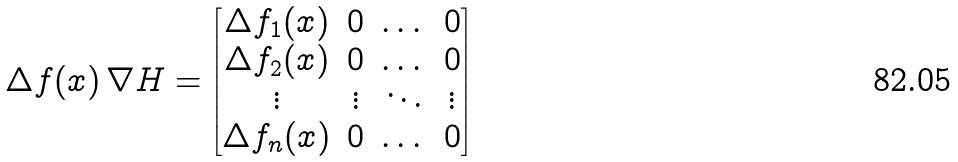<formula> <loc_0><loc_0><loc_500><loc_500>\Delta f ( x ) \, \nabla H = \begin{bmatrix} \Delta f _ { 1 } ( x ) & 0 & \dots & 0 \\ \Delta f _ { 2 } ( x ) & 0 & \dots & 0 \\ \vdots & \vdots & \ddots & \vdots \\ \Delta f _ { n } ( x ) & 0 & \dots & 0 \end{bmatrix}</formula> 